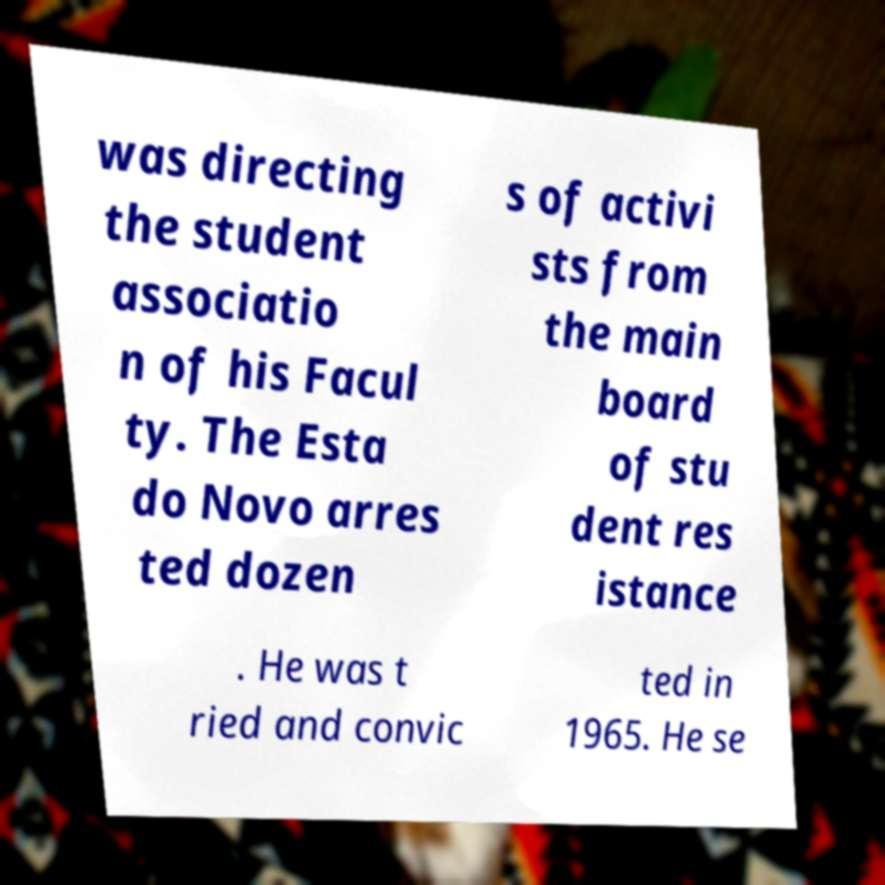Can you read and provide the text displayed in the image?This photo seems to have some interesting text. Can you extract and type it out for me? was directing the student associatio n of his Facul ty. The Esta do Novo arres ted dozen s of activi sts from the main board of stu dent res istance . He was t ried and convic ted in 1965. He se 